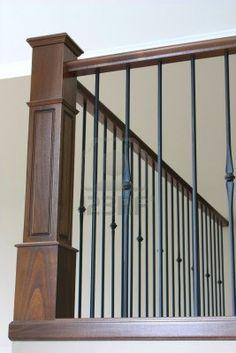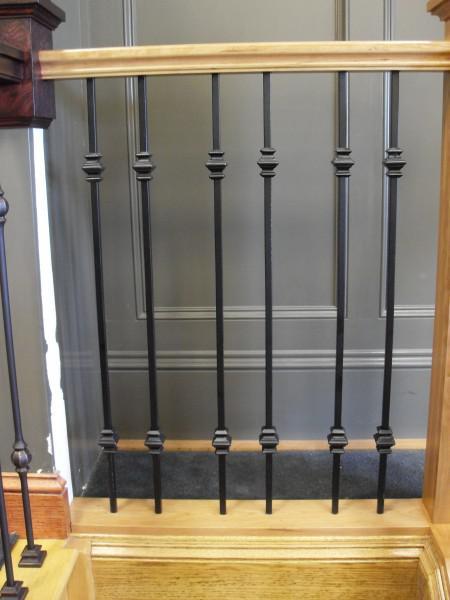The first image is the image on the left, the second image is the image on the right. Assess this claim about the two images: "The left image features corner posts with square cap tops and straight black vertical bars with no embellishments.". Correct or not? Answer yes or no. No. 